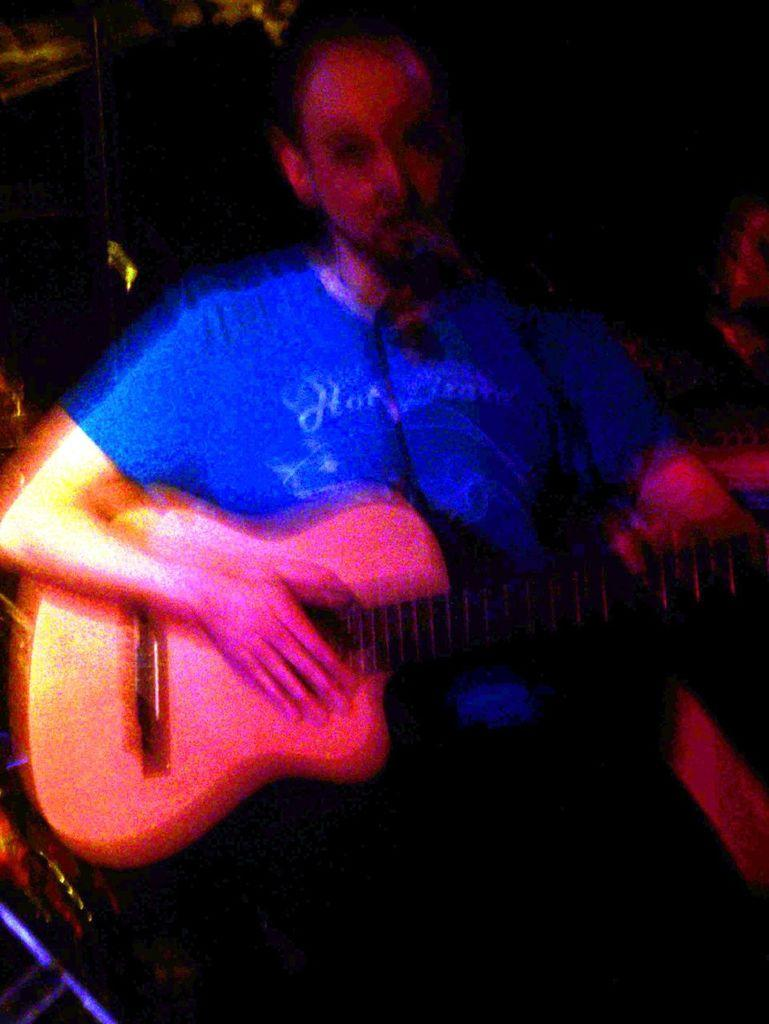What is the man in the image doing? The man is playing a guitar. How is the man playing the guitar? The man is using his hands to play the guitar. What is the man wearing in the image? The man is wearing a blue t-shirt. Can you see the man's wings in the image? There are no wings visible in the image; the man is a human playing a guitar. 